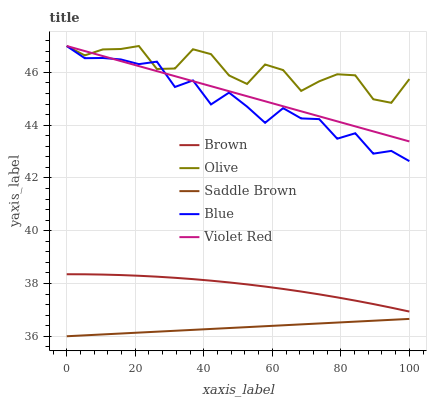Does Saddle Brown have the minimum area under the curve?
Answer yes or no. Yes. Does Olive have the maximum area under the curve?
Answer yes or no. Yes. Does Brown have the minimum area under the curve?
Answer yes or no. No. Does Brown have the maximum area under the curve?
Answer yes or no. No. Is Violet Red the smoothest?
Answer yes or no. Yes. Is Blue the roughest?
Answer yes or no. Yes. Is Brown the smoothest?
Answer yes or no. No. Is Brown the roughest?
Answer yes or no. No. Does Saddle Brown have the lowest value?
Answer yes or no. Yes. Does Brown have the lowest value?
Answer yes or no. No. Does Violet Red have the highest value?
Answer yes or no. Yes. Does Brown have the highest value?
Answer yes or no. No. Is Brown less than Blue?
Answer yes or no. Yes. Is Violet Red greater than Saddle Brown?
Answer yes or no. Yes. Does Olive intersect Blue?
Answer yes or no. Yes. Is Olive less than Blue?
Answer yes or no. No. Is Olive greater than Blue?
Answer yes or no. No. Does Brown intersect Blue?
Answer yes or no. No. 